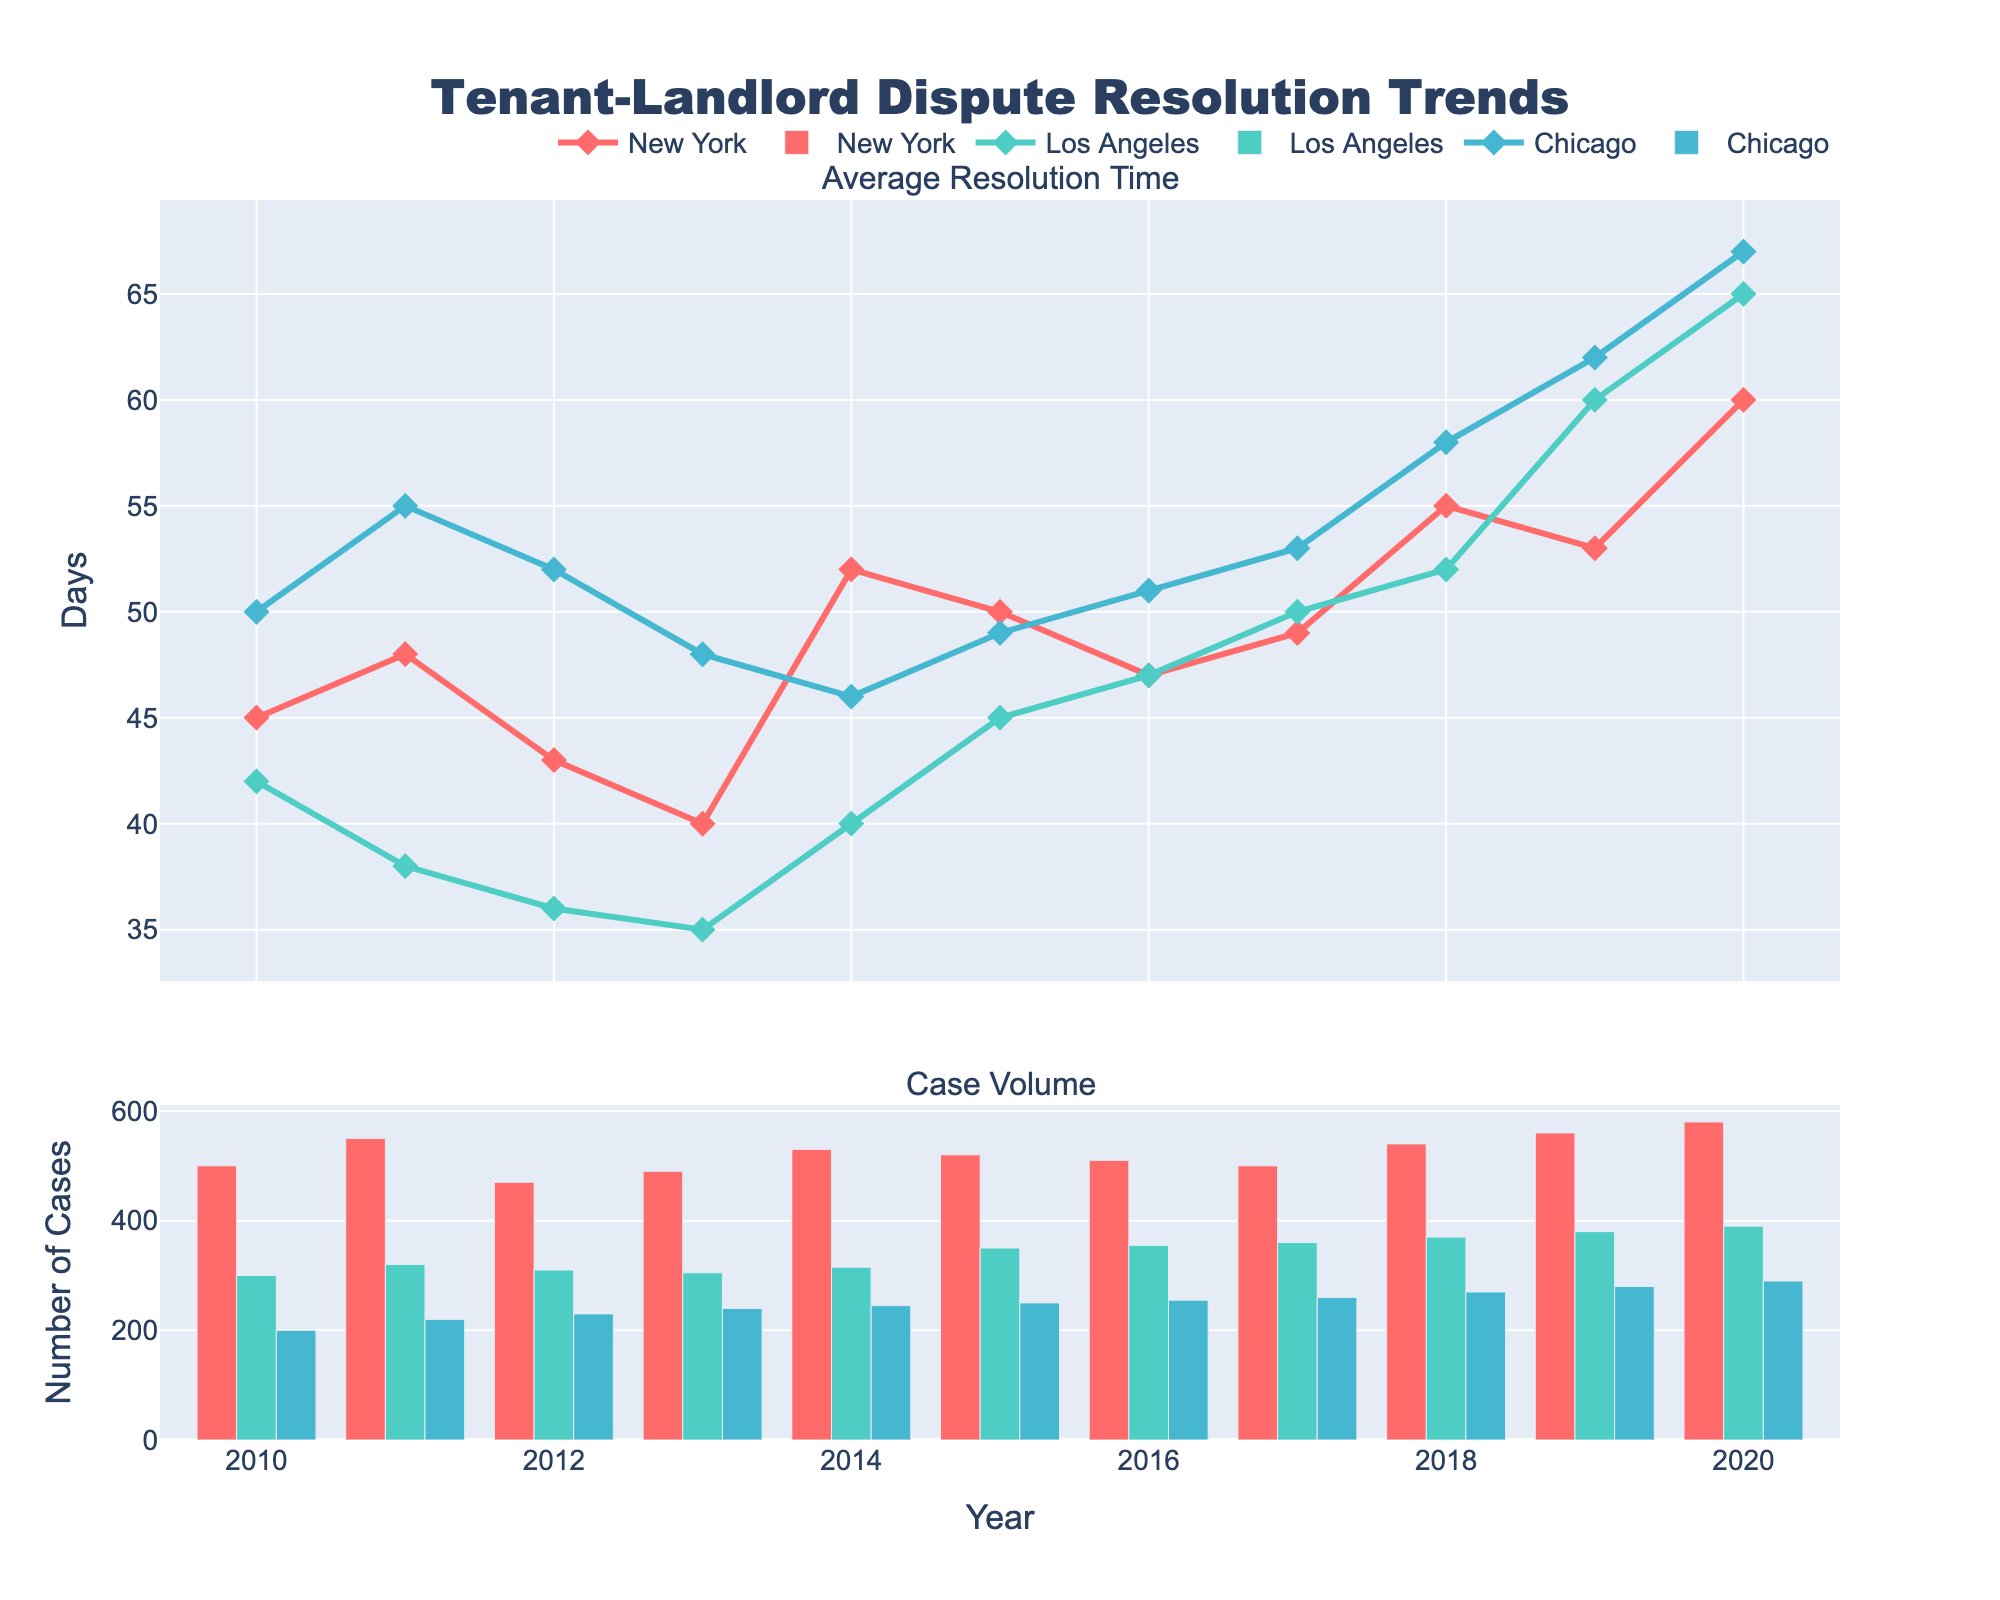What is the title of the figure? The title is usually placed at the top of the figure, often centered. For this figure, it is clearly visible as "Tenant-Landlord Dispute Resolution Trends".
Answer: Tenant-Landlord Dispute Resolution Trends What is the average resolution time for New York in 2018? Locate the line corresponding to New York in the top subplot for "Average Resolution Time". From the year 2018 on the x-axis, trace upwards to the data point connecting to the line. The value is indicated on the y-axis or the hover tooltip.
Answer: 55 days From which year does Los Angeles show a significant increase in case volume? Look at the bottom subplot for Los Angeles' bar line. Identify the year where there's a noticeable jump. It starts noticeably increasing in 2015.
Answer: 2015 Which location had the longest average resolution time in any single year, and in which year? For each location, trace the highest peak in the top subplot for "Average Resolution Time". Compare these peaks across all years and locations. Los Angeles had the longest average resolution time in 2020.
Answer: Los Angeles in 2020 What trend do you observe in Chicago's case volume from 2010 to 2020? In the bottom subplot, follow the bars representing Chicago from 2010 through 2020. Observe if it shows an increasing, decreasing, or stable trend.
Answer: Increasing trend How does the average resolution time in Los Angeles change from 2013 to 2014? In the top subplot for "Average Resolution Time", check the data points for Los Angeles at 2013 and 2014. Identify if it's an increase or decrease. It increased from 35 to 40 days.
Answer: Increased by 5 days Which location had the most case volume in 2019? In the bottom subplot, note the height of the bars for each location in 2019. The highest bar indicates the location with the most cases. New York had the most case volume in 2019.
Answer: New York In what year did New York experience the highest average resolution time? In the top subplot, find the peak point for New York on the plot. The highest value is in 2020.
Answer: 2020 Compare the trends of the average resolution time from 2010 to 2020 for New York and Los Angeles. Trace the lines for both locations on the top subplot from 2010 to 2020. Identify if they generally increase, decrease, or fluctuate. New York fluctuates with an overall increase while Los Angeles increases steadily.
Answer: Fluctuates for New York, steadily increases for Los Angeles What observations can you make about the trend in case volume for Chicago starting from 2010 to 2020? Check the bottom subplot and follow the case volumes for Chicago in each year. Note if it remains stable, increases, or decreases. Chicago's case volume shows a consistent increase from 200 to 290 cases.
Answer: Consistent increase 